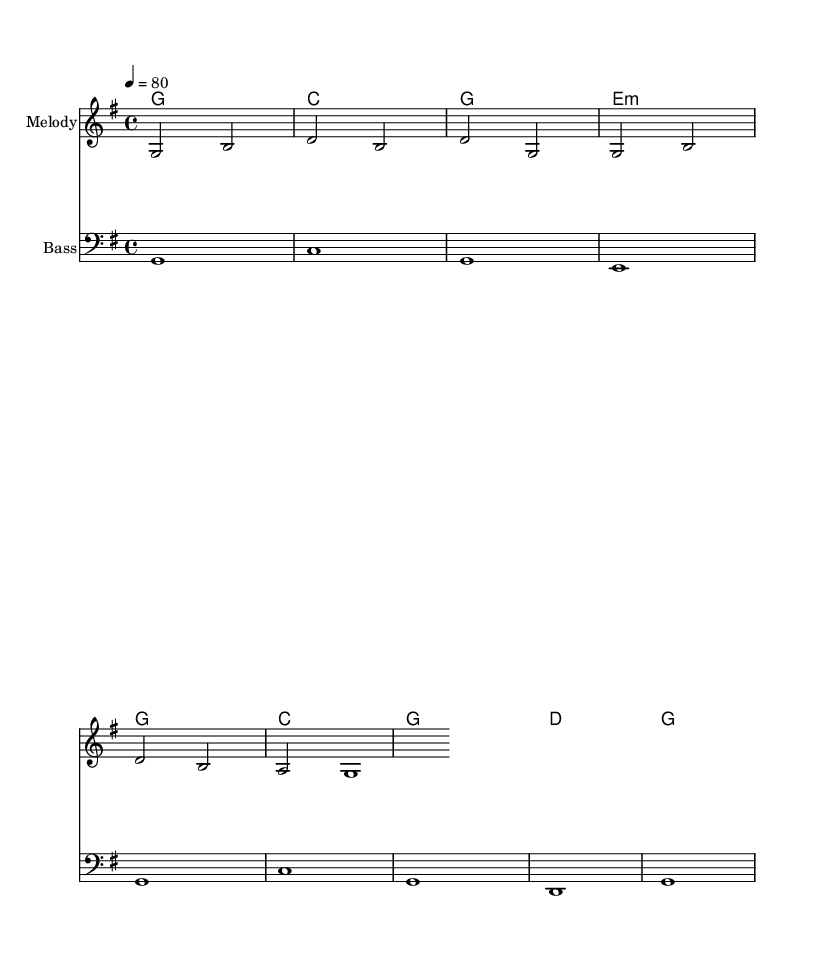What is the key signature of this music? The key signature is G major, indicated by one sharp (F#). This is visually represented at the beginning of the staff.
Answer: G major What is the time signature of this music? The time signature is 4/4, as indicated at the beginning of the score. This means there are four beats in a measure, and a quarter note gets one beat.
Answer: 4/4 What is the tempo marking for this piece? The tempo marking is marked as "4 = 80," indicating the music should be played at 80 beats per minute, with each quarter note getting a beat.
Answer: 80 What is the first chord played in the harmony? The first chord is G major, represented in the chord symbols above the staff. This is seen in the chordmode section where the first chord appears.
Answer: G major How many measures are in the score? The score contains two measures in total, as counted from the melody line. Each group of notes separated by vertical lines represents a measure.
Answer: 2 What is the instrument name for the melody staff? The melody staff is labeled as "Melody," clearly indicated at the beginning of that staff section.
Answer: Melody Is there a bass line present in this score? Yes, there is a bass line indicated by a separate staff labeled "Bass," which suggests additional harmonic support below the melody.
Answer: Yes 